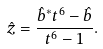<formula> <loc_0><loc_0><loc_500><loc_500>\hat { z } = \frac { \hat { b } ^ { * } t ^ { 6 } - \hat { b } } { t ^ { 6 } - 1 } .</formula> 